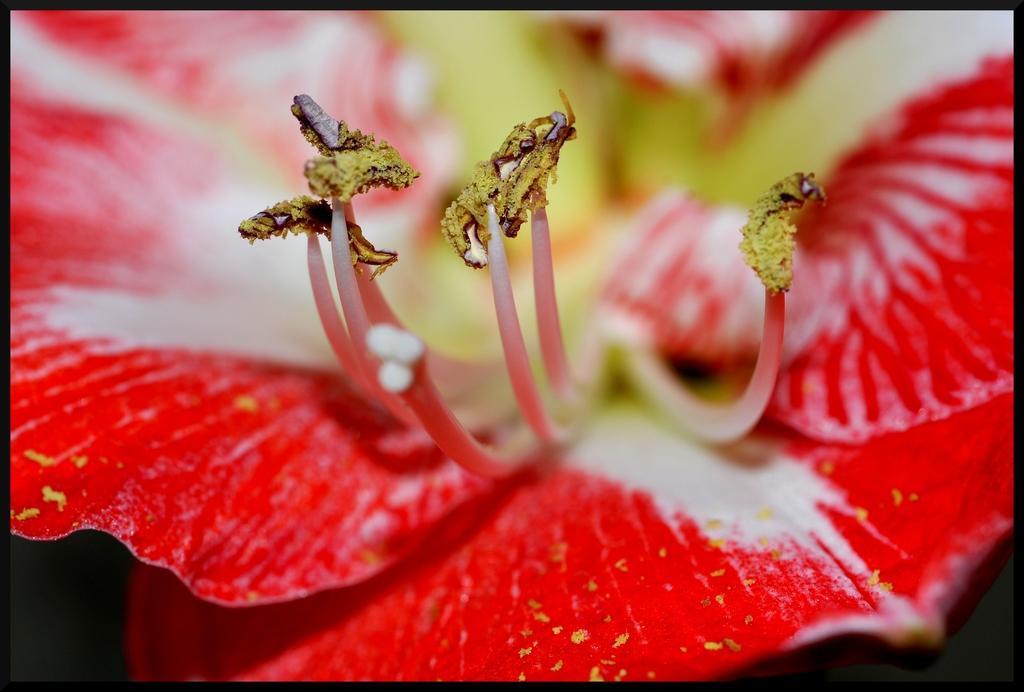How would you summarize this image in a sentence or two? In this image we can see a flower which is in red color. 